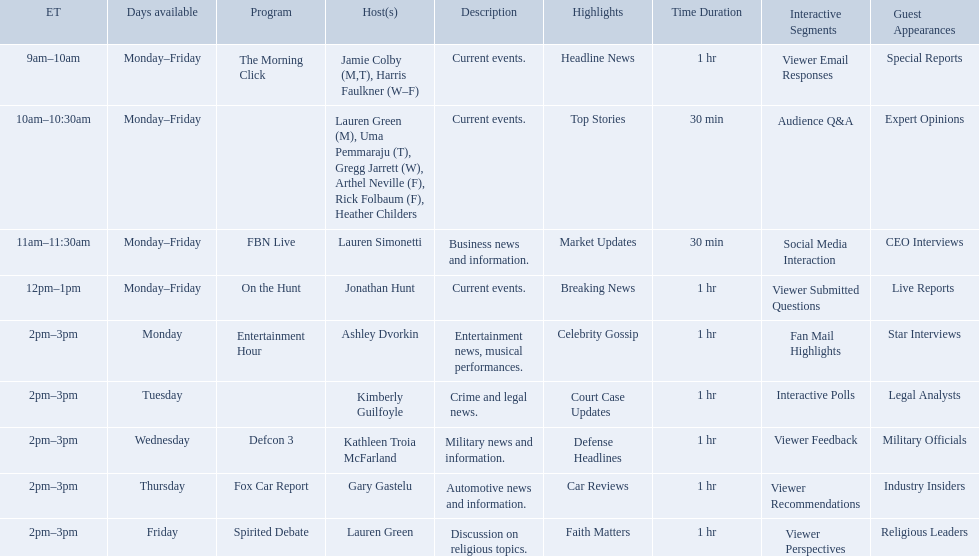Which programs broadcast by fox news channel hosts are listed? Jamie Colby (M,T), Harris Faulkner (W–F), Lauren Green (M), Uma Pemmaraju (T), Gregg Jarrett (W), Arthel Neville (F), Rick Folbaum (F), Heather Childers, Lauren Simonetti, Jonathan Hunt, Ashley Dvorkin, Kimberly Guilfoyle, Kathleen Troia McFarland, Gary Gastelu, Lauren Green. Of those, who have shows on friday? Jamie Colby (M,T), Harris Faulkner (W–F), Lauren Green (M), Uma Pemmaraju (T), Gregg Jarrett (W), Arthel Neville (F), Rick Folbaum (F), Heather Childers, Lauren Simonetti, Jonathan Hunt, Lauren Green. Of those, whose is at 2 pm? Lauren Green. What are the names of all the hosts? Jamie Colby (M,T), Harris Faulkner (W–F), Lauren Green (M), Uma Pemmaraju (T), Gregg Jarrett (W), Arthel Neville (F), Rick Folbaum (F), Heather Childers, Lauren Simonetti, Jonathan Hunt, Ashley Dvorkin, Kimberly Guilfoyle, Kathleen Troia McFarland, Gary Gastelu, Lauren Green. What hosts have a show on friday? Jamie Colby (M,T), Harris Faulkner (W–F), Lauren Green (M), Uma Pemmaraju (T), Gregg Jarrett (W), Arthel Neville (F), Rick Folbaum (F), Heather Childers, Lauren Simonetti, Jonathan Hunt, Lauren Green. Can you give me this table as a dict? {'header': ['ET', 'Days available', 'Program', 'Host(s)', 'Description', 'Highlights', 'Time Duration', 'Interactive Segments', 'Guest Appearances'], 'rows': [['9am–10am', 'Monday–Friday', 'The Morning Click', 'Jamie Colby (M,T), Harris Faulkner (W–F)', 'Current events.', 'Headline News', '1 hr', 'Viewer Email Responses', 'Special Reports'], ['10am–10:30am', 'Monday–Friday', '', 'Lauren Green (M), Uma Pemmaraju (T), Gregg Jarrett (W), Arthel Neville (F), Rick Folbaum (F), Heather Childers', 'Current events.', 'Top Stories', '30 min', 'Audience Q&A', 'Expert Opinions'], ['11am–11:30am', 'Monday–Friday', 'FBN Live', 'Lauren Simonetti', 'Business news and information.', 'Market Updates', '30 min', 'Social Media Interaction', 'CEO Interviews'], ['12pm–1pm', 'Monday–Friday', 'On the Hunt', 'Jonathan Hunt', 'Current events.', 'Breaking News', '1 hr', 'Viewer Submitted Questions', 'Live Reports '], ['2pm–3pm', 'Monday', 'Entertainment Hour', 'Ashley Dvorkin', 'Entertainment news, musical performances.', 'Celebrity Gossip', '1 hr', 'Fan Mail Highlights', 'Star Interviews'], ['2pm–3pm', 'Tuesday', '', 'Kimberly Guilfoyle', 'Crime and legal news.', 'Court Case Updates', '1 hr', 'Interactive Polls', 'Legal Analysts'], ['2pm–3pm', 'Wednesday', 'Defcon 3', 'Kathleen Troia McFarland', 'Military news and information.', 'Defense Headlines', '1 hr', 'Viewer Feedback', 'Military Officials'], ['2pm–3pm', 'Thursday', 'Fox Car Report', 'Gary Gastelu', 'Automotive news and information.', 'Car Reviews', '1 hr', 'Viewer Recommendations', 'Industry Insiders'], ['2pm–3pm', 'Friday', 'Spirited Debate', 'Lauren Green', 'Discussion on religious topics.', 'Faith Matters', '1 hr', 'Viewer Perspectives', 'Religious Leaders']]} Of these hosts, which is the only host with only friday available? Lauren Green. 